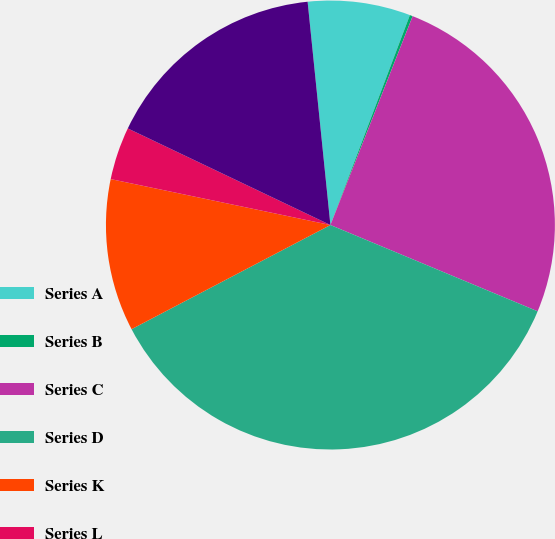Convert chart to OTSL. <chart><loc_0><loc_0><loc_500><loc_500><pie_chart><fcel>Series A<fcel>Series B<fcel>Series C<fcel>Series D<fcel>Series K<fcel>Series L<fcel>Series N<nl><fcel>7.38%<fcel>0.21%<fcel>25.31%<fcel>36.04%<fcel>10.96%<fcel>3.8%<fcel>16.3%<nl></chart> 